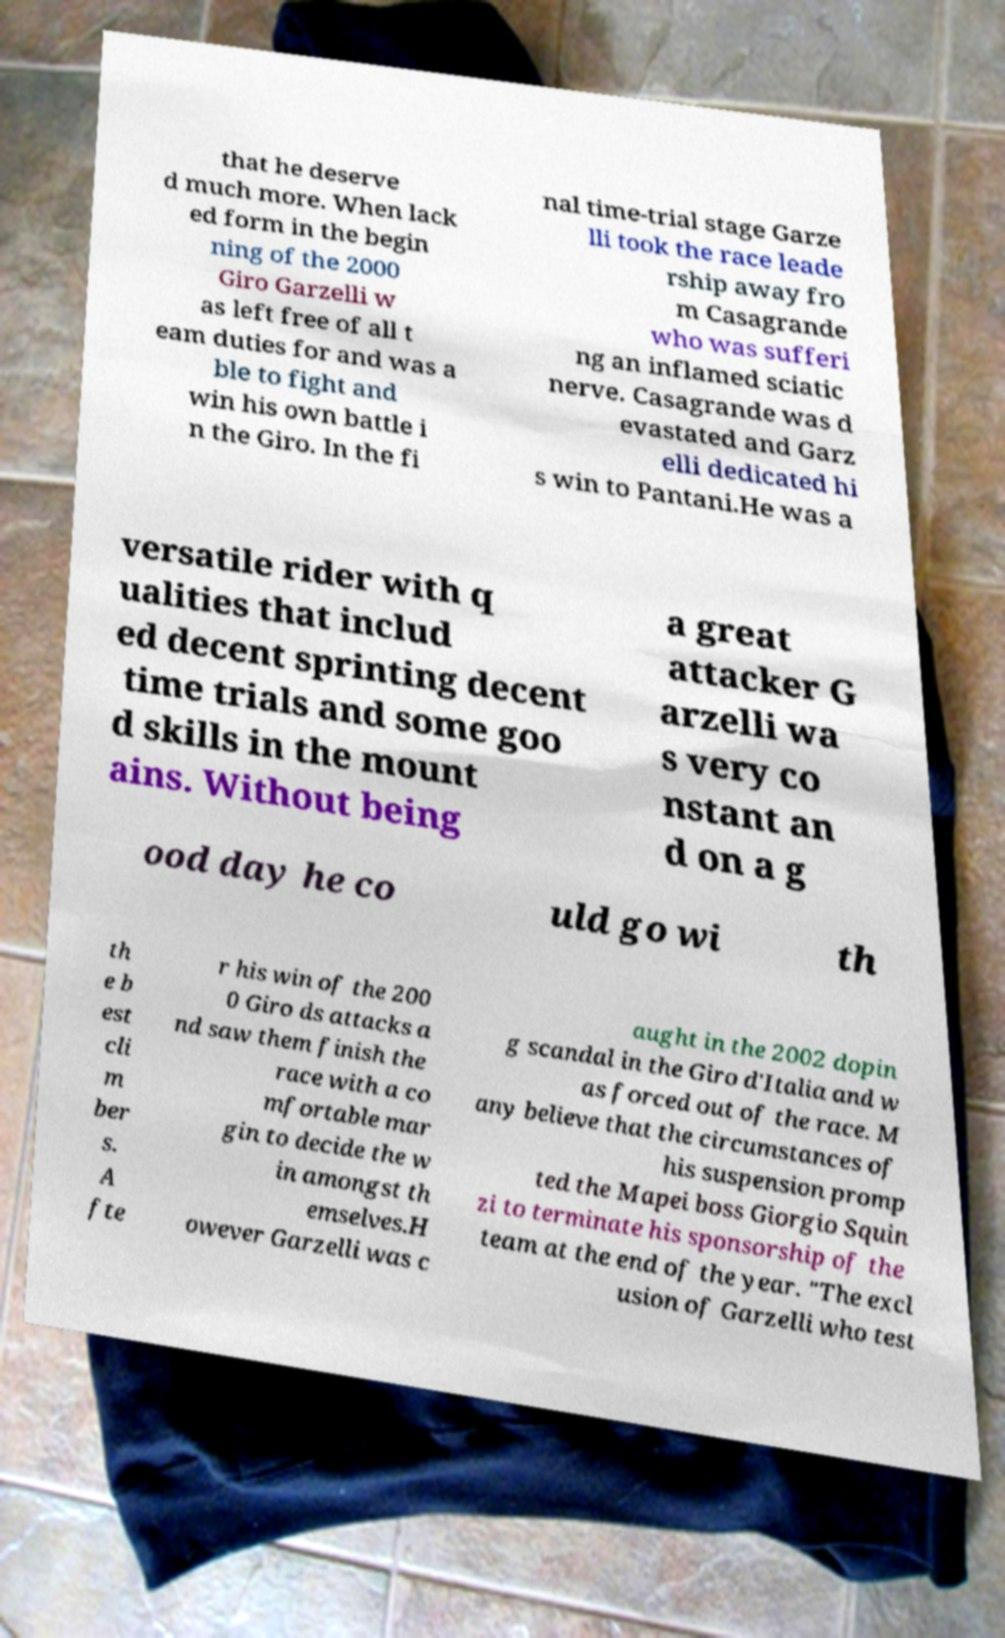Please identify and transcribe the text found in this image. that he deserve d much more. When lack ed form in the begin ning of the 2000 Giro Garzelli w as left free of all t eam duties for and was a ble to fight and win his own battle i n the Giro. In the fi nal time-trial stage Garze lli took the race leade rship away fro m Casagrande who was sufferi ng an inflamed sciatic nerve. Casagrande was d evastated and Garz elli dedicated hi s win to Pantani.He was a versatile rider with q ualities that includ ed decent sprinting decent time trials and some goo d skills in the mount ains. Without being a great attacker G arzelli wa s very co nstant an d on a g ood day he co uld go wi th th e b est cli m ber s. A fte r his win of the 200 0 Giro ds attacks a nd saw them finish the race with a co mfortable mar gin to decide the w in amongst th emselves.H owever Garzelli was c aught in the 2002 dopin g scandal in the Giro d'Italia and w as forced out of the race. M any believe that the circumstances of his suspension promp ted the Mapei boss Giorgio Squin zi to terminate his sponsorship of the team at the end of the year. "The excl usion of Garzelli who test 